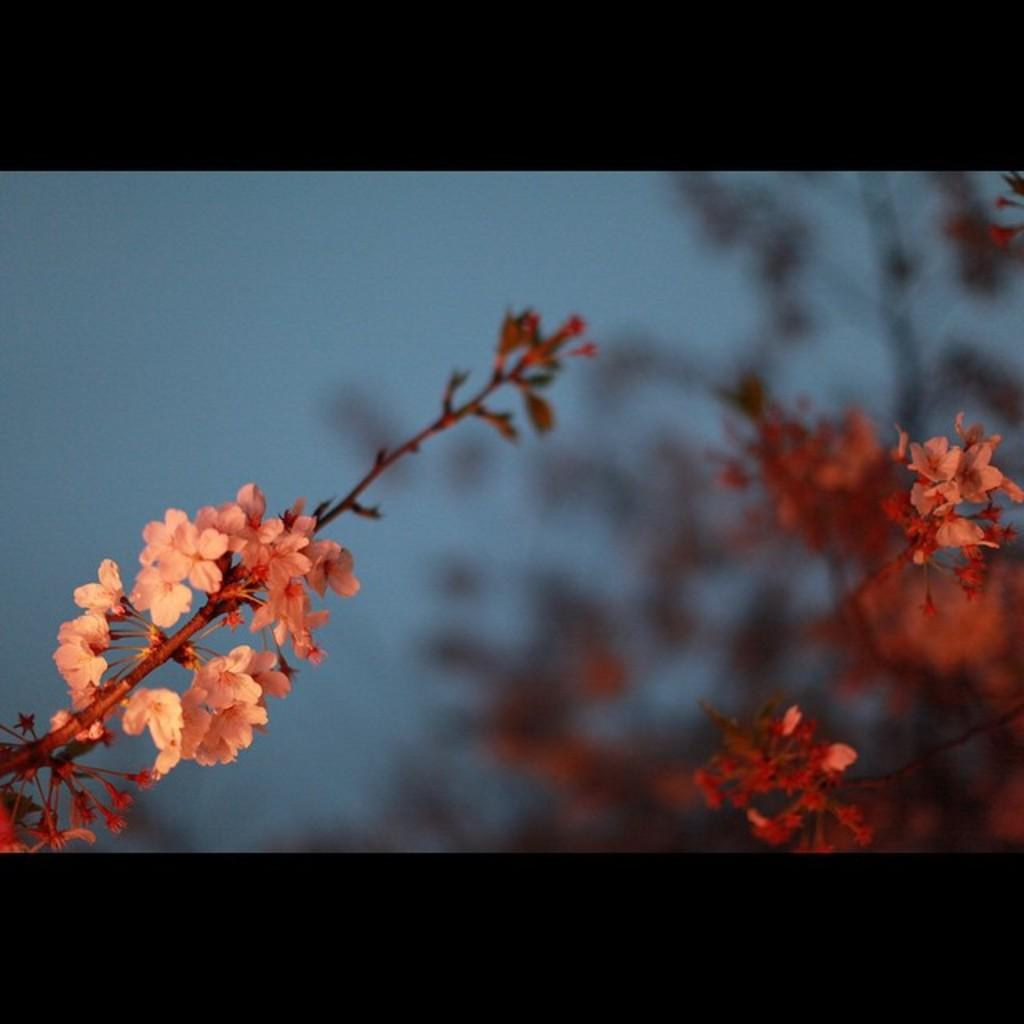What type of plants are in the image? There are flowers in the image. How are the flowers attached to the stems? The flowers are on stems. Can you describe the background of the image? The background of the image is blurry. What type of flight is visible in the image? There is no flight present in the image; it features flowers on stems with a blurry background. 